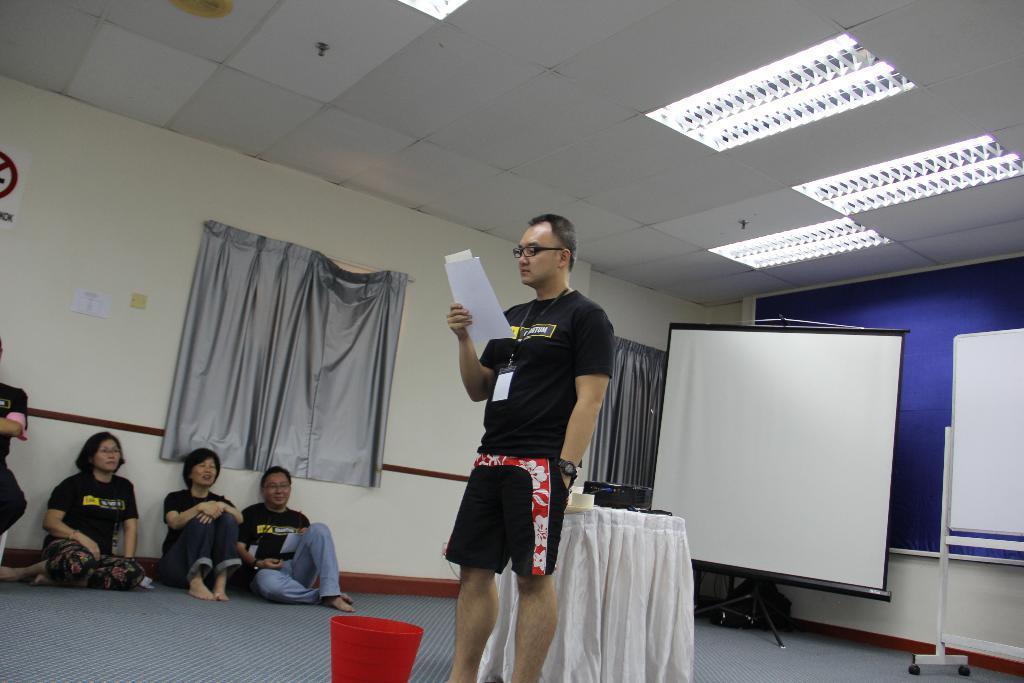In one or two sentences, can you explain what this image depicts? In this picture I can see there is a man standing and he is wearing a black shirt and trouser. He is looking into the paper and held in his right hand. There are few people sitting at left side and there is a screen in the backdrop and there is a whiteboard in the backdrop. There is a table and there are few lights attached to the ceiling. 